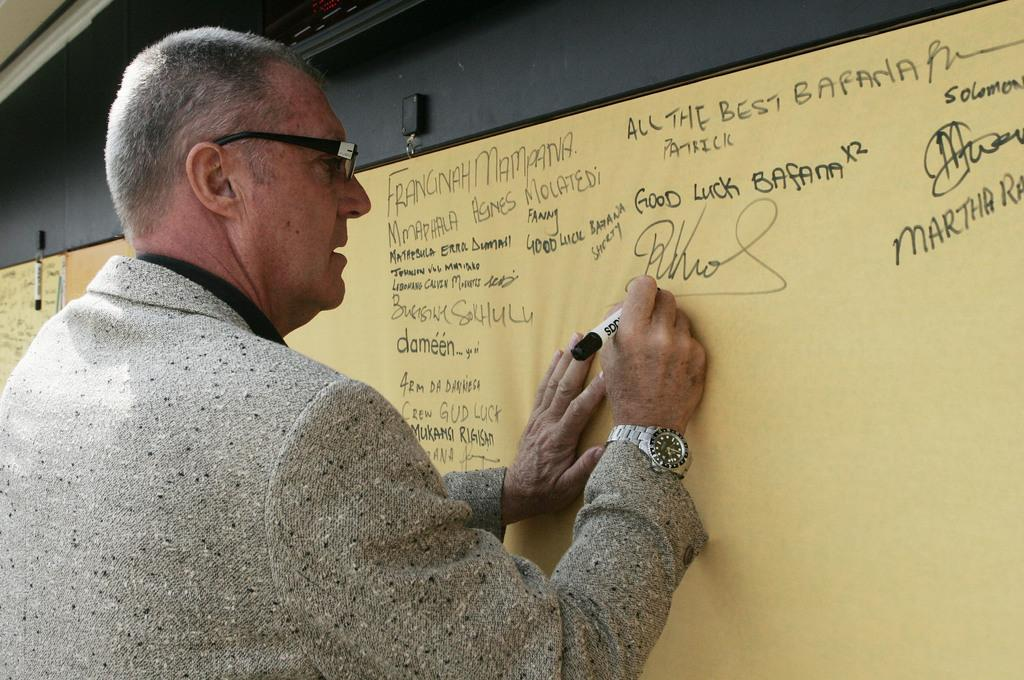What is the main subject of the image? There is a person in the image. What accessories is the person wearing? The person is wearing specs and a watch. What activity is the person engaged in? The person is writing on a board with a marker. What color is the board? There is a yellow board in the image. Can you read what is written on the board? Unfortunately, the content of the writing cannot be determined from the image. What hobbies does the secretary have outside of work? There is no secretary present in the image, and therefore no information about their hobbies can be determined. --- Facts: 1. There is a car in the image. 2. The car is red. 3. The car has four wheels. 4. There are people in the car. 5. The car has a sunroof. Absurd Topics: parrot, ocean, mountain Conversation: What is the main subject of the image? There is a car in the image. What color is the car? The car is red. How many wheels does the car have? The car has four wheels. Are there any passengers in the car? Yes, there are people in the car. What feature does the car have on its roof? The car has a sunroof. Reasoning: Let's think step by step in order to produce the conversation. We start by identifying the main subject of the image, which is the car. Then, we describe the color and number of wheels of the car. Next, we mention the presence of passengers in the car. Finally, we focus on a specific feature of the car, which is the sunroof. Absurd Question/Answer: Can you see any parrots flying over the ocean near the mountain in the image? There are no parrots, ocean, or mountains present in the image; it features a red car with people inside. 